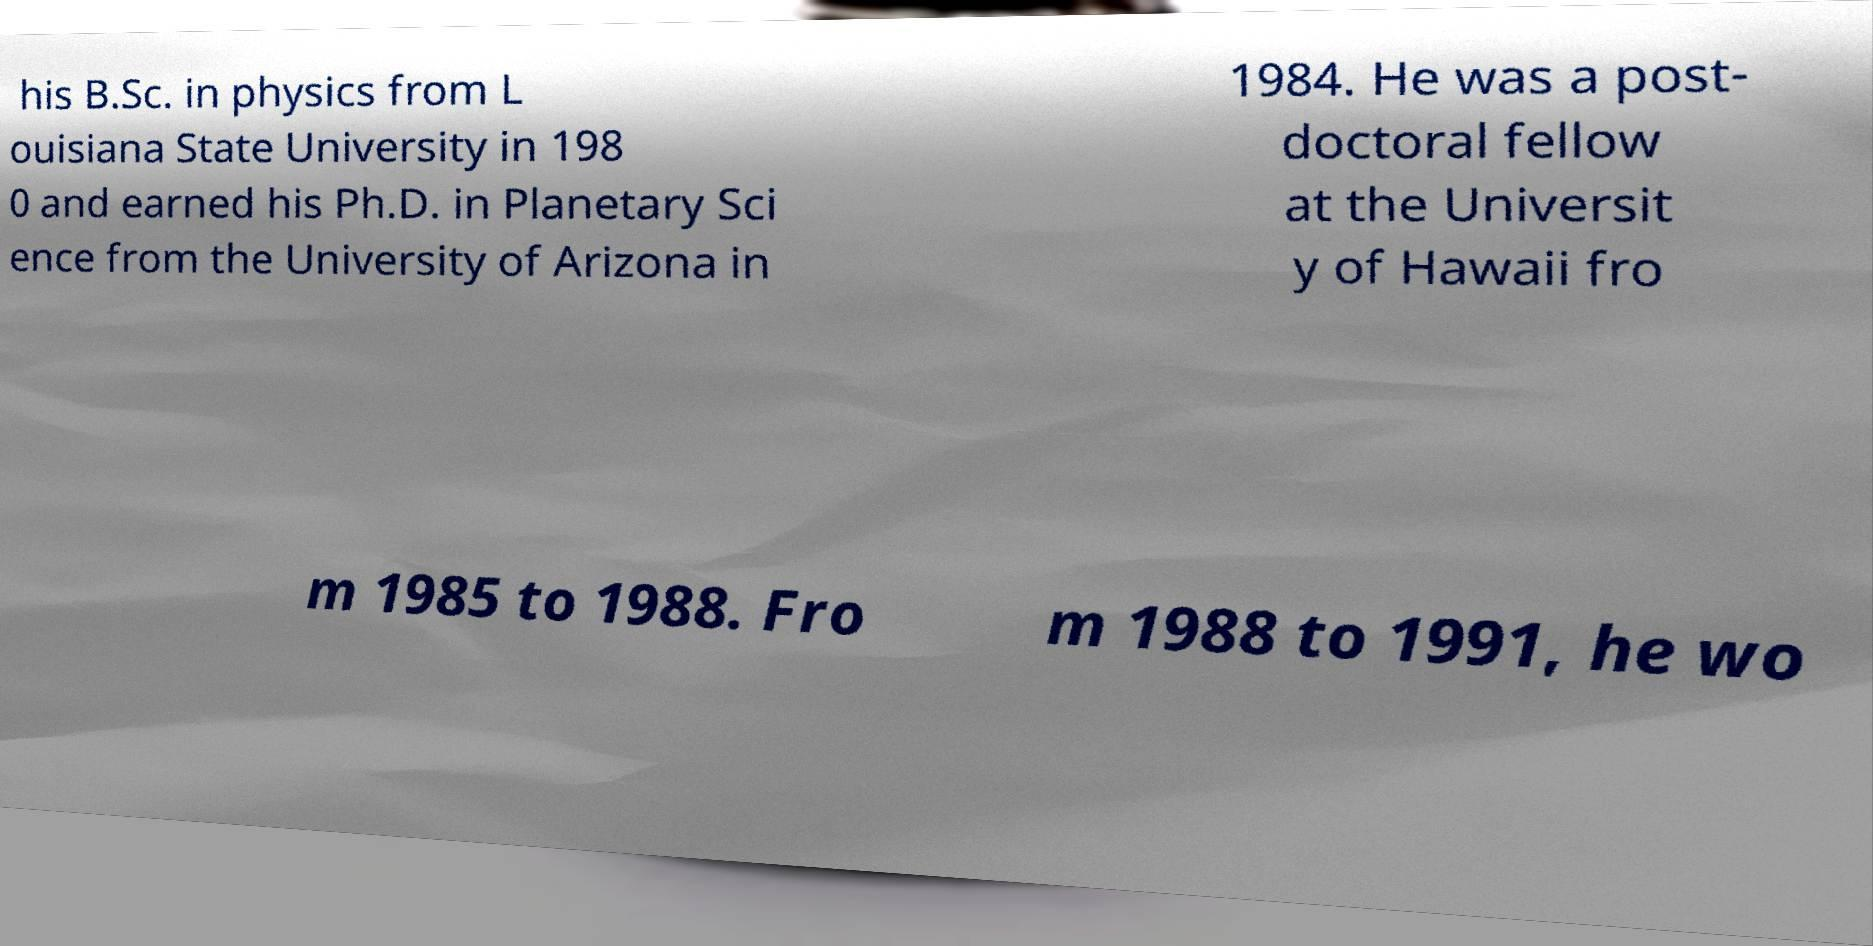Please read and relay the text visible in this image. What does it say? his B.Sc. in physics from L ouisiana State University in 198 0 and earned his Ph.D. in Planetary Sci ence from the University of Arizona in 1984. He was a post- doctoral fellow at the Universit y of Hawaii fro m 1985 to 1988. Fro m 1988 to 1991, he wo 